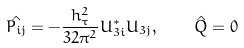Convert formula to latex. <formula><loc_0><loc_0><loc_500><loc_500>\hat { P _ { i j } } = - \frac { h _ { \tau } ^ { 2 } } { 3 2 \pi ^ { 2 } } U _ { 3 i } ^ { \ast } U _ { 3 j } , \quad \hat { Q } = 0</formula> 